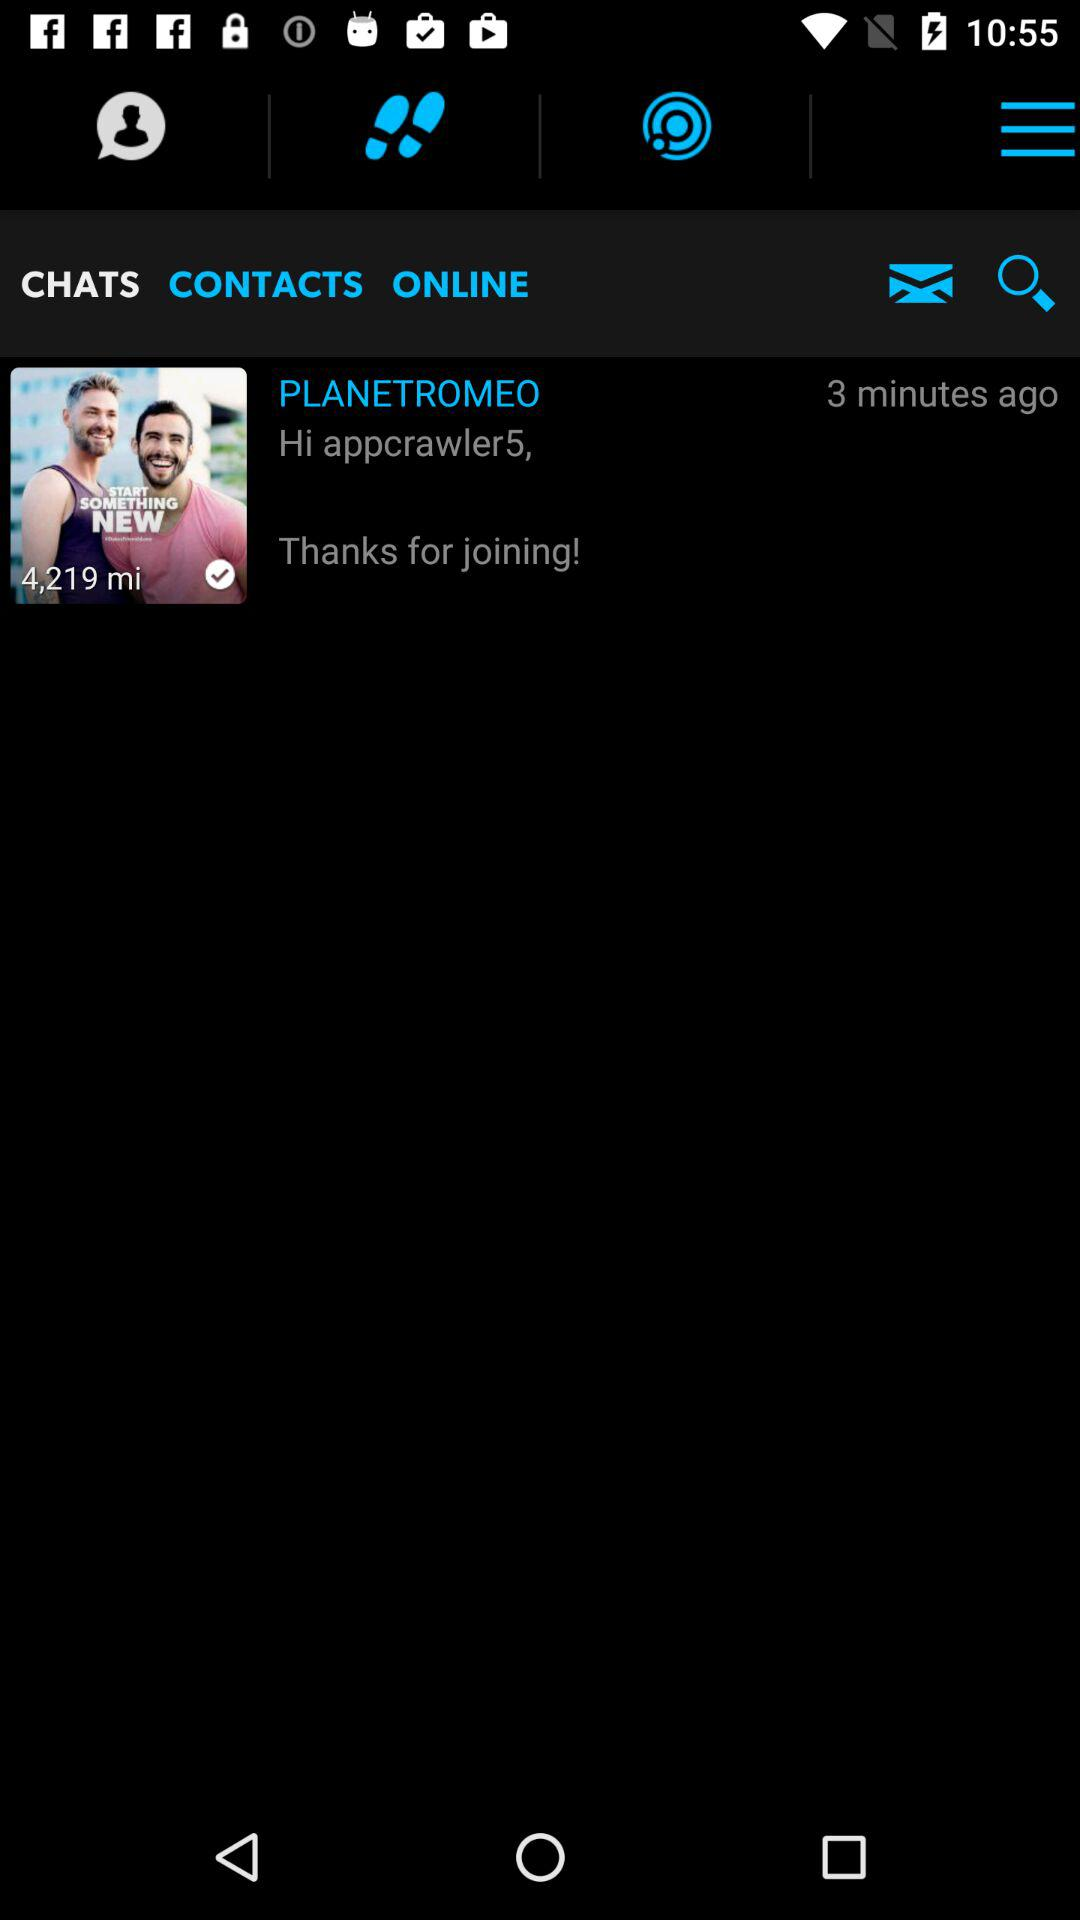How many minutes ago did "PLANETROMEO" send the message? "PLANETROMEO" sent the message 3 minutes ago. 